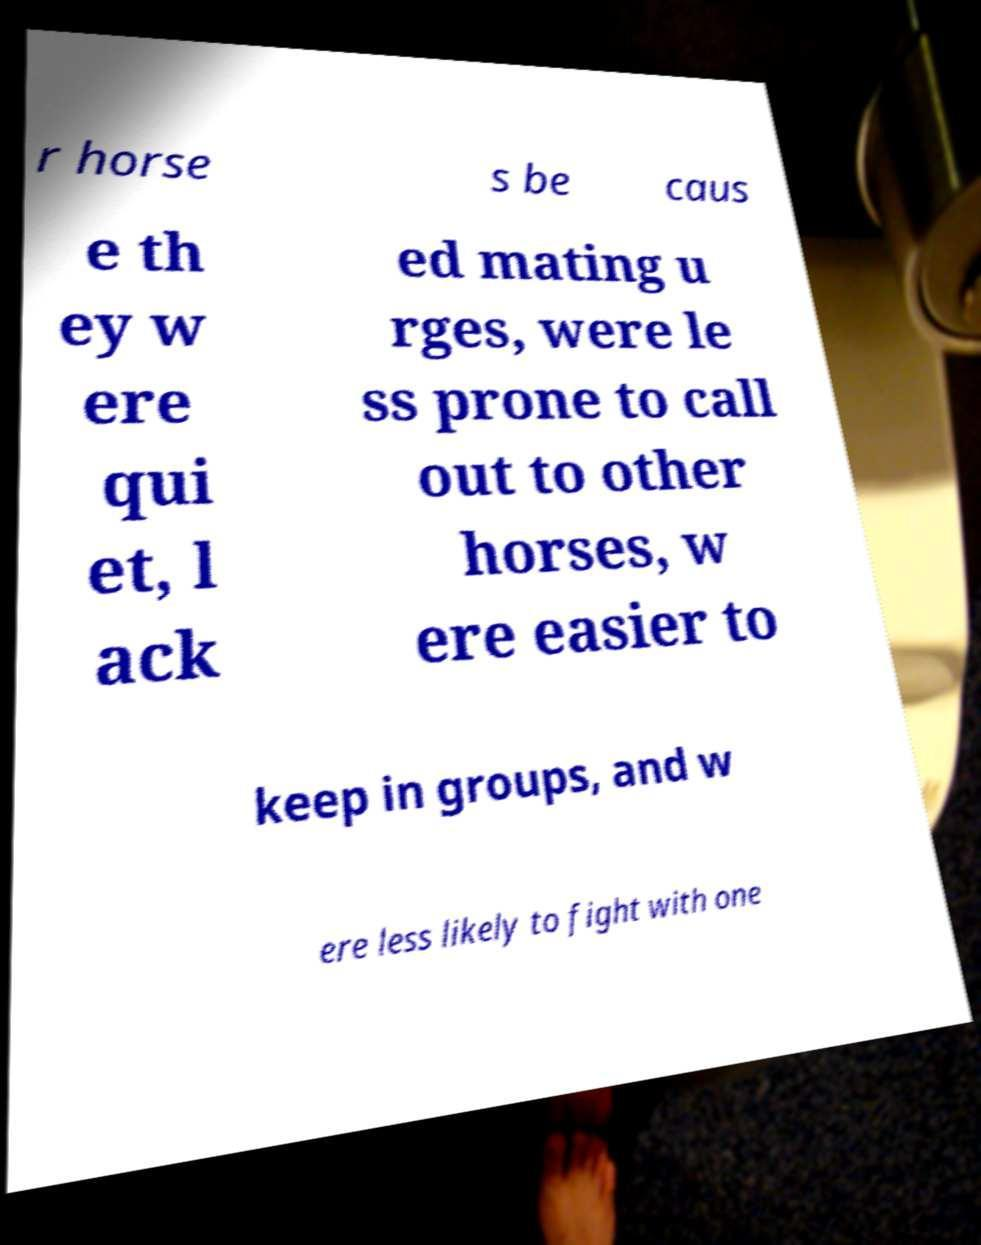Please identify and transcribe the text found in this image. r horse s be caus e th ey w ere qui et, l ack ed mating u rges, were le ss prone to call out to other horses, w ere easier to keep in groups, and w ere less likely to fight with one 